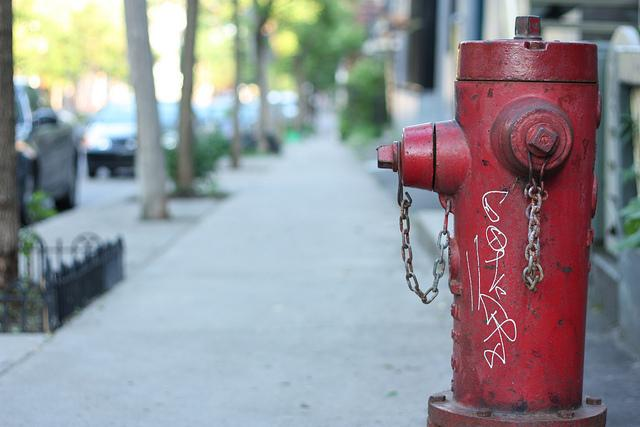Why are there chains on the red thing?

Choices:
A) prevent break-in
B) hold lids
C) purely aesthetic
D) provides strength hold lids 